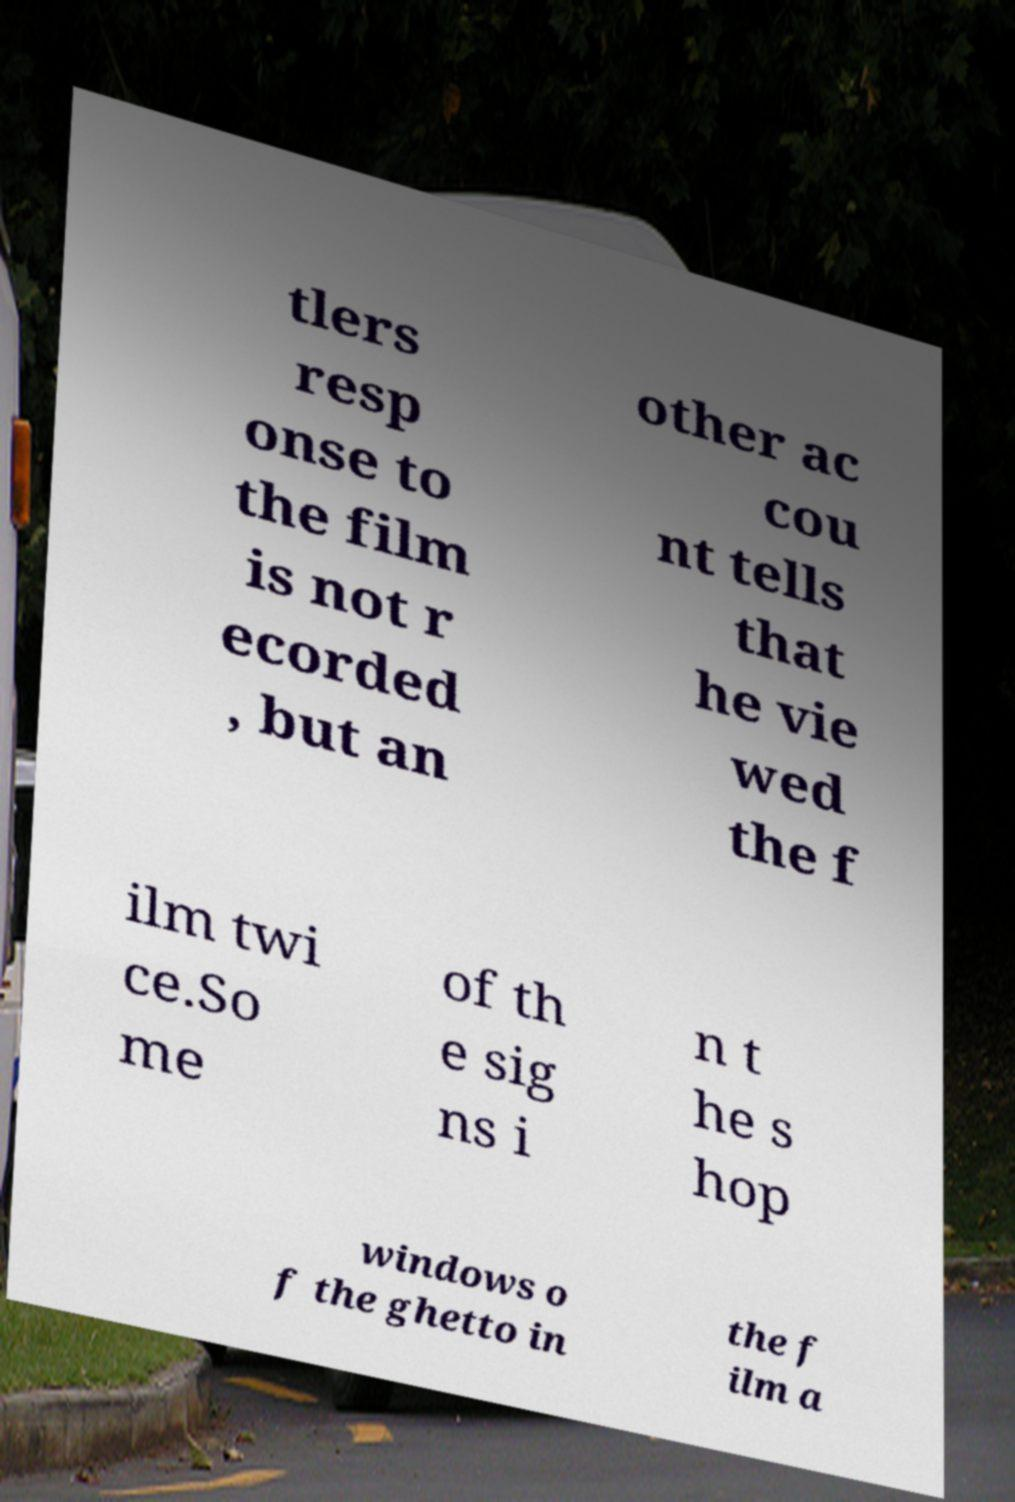Please read and relay the text visible in this image. What does it say? tlers resp onse to the film is not r ecorded , but an other ac cou nt tells that he vie wed the f ilm twi ce.So me of th e sig ns i n t he s hop windows o f the ghetto in the f ilm a 